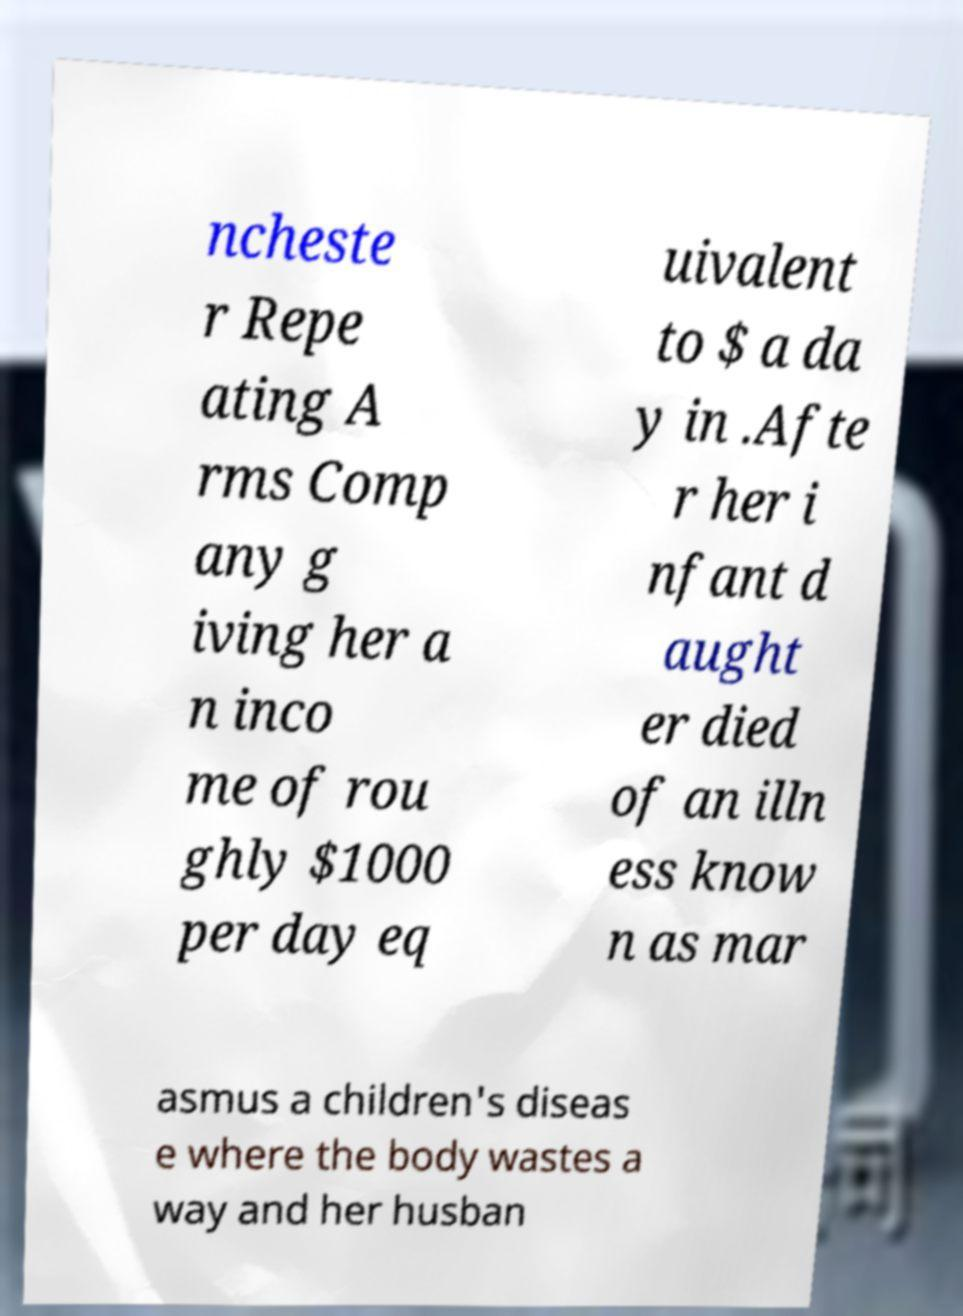Please identify and transcribe the text found in this image. ncheste r Repe ating A rms Comp any g iving her a n inco me of rou ghly $1000 per day eq uivalent to $ a da y in .Afte r her i nfant d aught er died of an illn ess know n as mar asmus a children's diseas e where the body wastes a way and her husban 